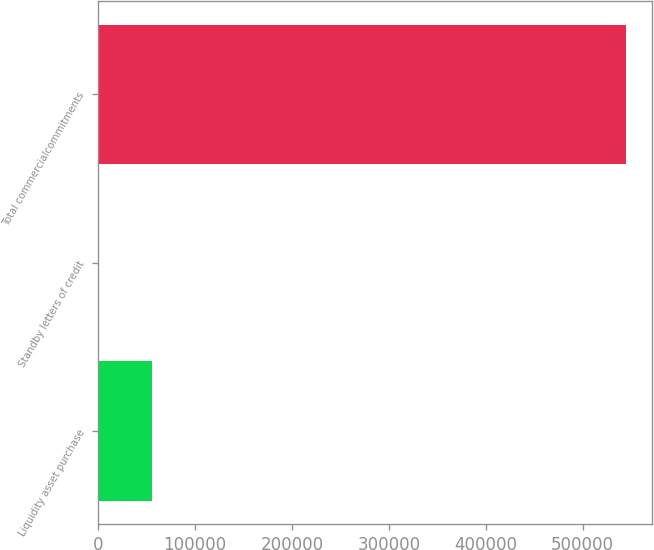<chart> <loc_0><loc_0><loc_500><loc_500><bar_chart><fcel>Liquidity asset purchase<fcel>Standby letters of credit<fcel>Total commercialcommitments<nl><fcel>55147.6<fcel>793<fcel>544339<nl></chart> 